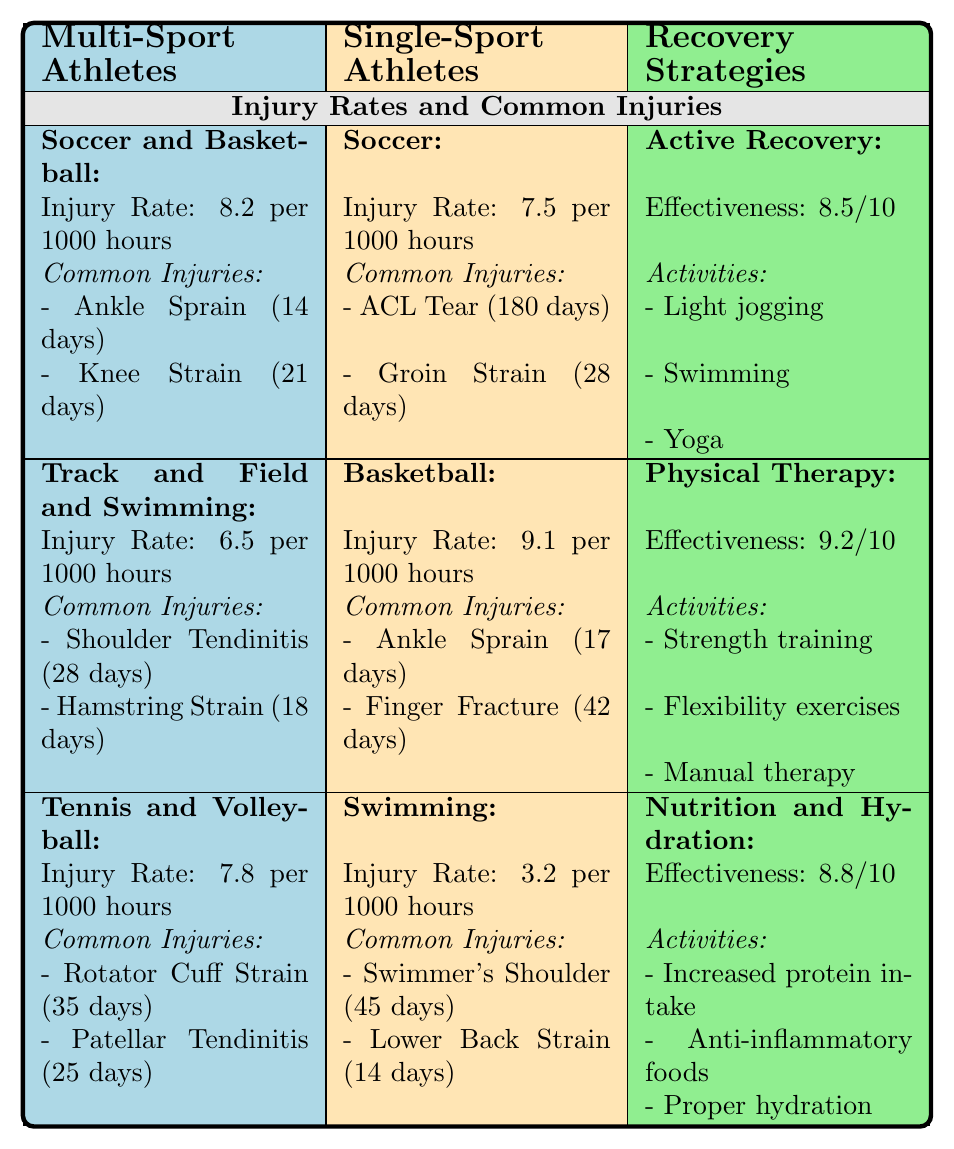What is the injury rate for multi-sport athletes in soccer and basketball? In the table, the injury rate for multi-sport athletes in the category "Soccer and Basketball" is explicitly listed as 8.2 per 1000 hours.
Answer: 8.2 per 1000 hours Which single-sport athlete has the highest injury rate? By looking at the injury rates for single-sport athletes, "Basketball" has the highest injury rate at 9.1 per 1000 hours, while "Soccer" and "Swimming" have lower rates.
Answer: Basketball What is the average recovery time for multi-sport athletes' common injuries in tennis and volleyball? The common injuries listed for multi-sport athletes participating in tennis and volleyball are "Rotator Cuff Strain" (35 days) and "Patellar Tendinitis" (25 days). The average recovery time is (35 + 25) / 2 = 30 days.
Answer: 30 days Do multi-sport athletes have a lower overall injury rate compared to single-sport athletes? The average injury rate for multi-sport athletes is (8.2 + 6.5 + 7.8) / 3 = 7.5 per 1000 hours. For single-sport athletes, it is (7.5 + 9.1 + 3.2) / 3 = 6.6 per 1000 hours. Since 7.5 is greater, the statement is false.
Answer: No What is the effect of physical therapy according to the recovery strategies? The table shows that physical therapy has an effectiveness rating of 9.2 out of 10, indicating it is highly effective for recovery.
Answer: 9.2 out of 10 How much more recovery time does a single-sport athlete with an ACL tear typically need compared to a multi-sport athlete with an ankle sprain? The recovery time for an ACL tear is 180 days, while for an ankle sprain (common in multi-sport athletes) it is 14 days. The difference is 180 - 14 = 166 days.
Answer: 166 days Are shoulder injuries more common among single-sport or multi-sport athletes based on the table? The table shows a common injury of "Shoulder Tendinitis" for multi-sport athletes and "Swimmer's Shoulder" for single-sport athletes. Since both types have shoulder-related injuries, it's not definitive; however, both groups experience shoulder injuries.
Answer: Both groups experience shoulder injuries What should a multi-sport athlete prioritize according to the recommended activities for recovery? The recovery strategies for multi-sport athletes include activities like light jogging, swimming, and yoga under active recovery. These activities help in general recovery and should be prioritized.
Answer: Light jogging, swimming, and yoga What is the average recovery time for all common injuries listed for both groups of athletes? The common injuries for multi-sport athletes total (14 + 21 + 28 + 18 + 35 + 25) = 141 days for 6 injuries, and for single-sport athletes, it total (180 + 28 + 17 + 42 + 45 + 14) = 326 days for 6 injuries, making it (141 + 326) / 12 = 38.92 days.
Answer: Approximately 39 days 